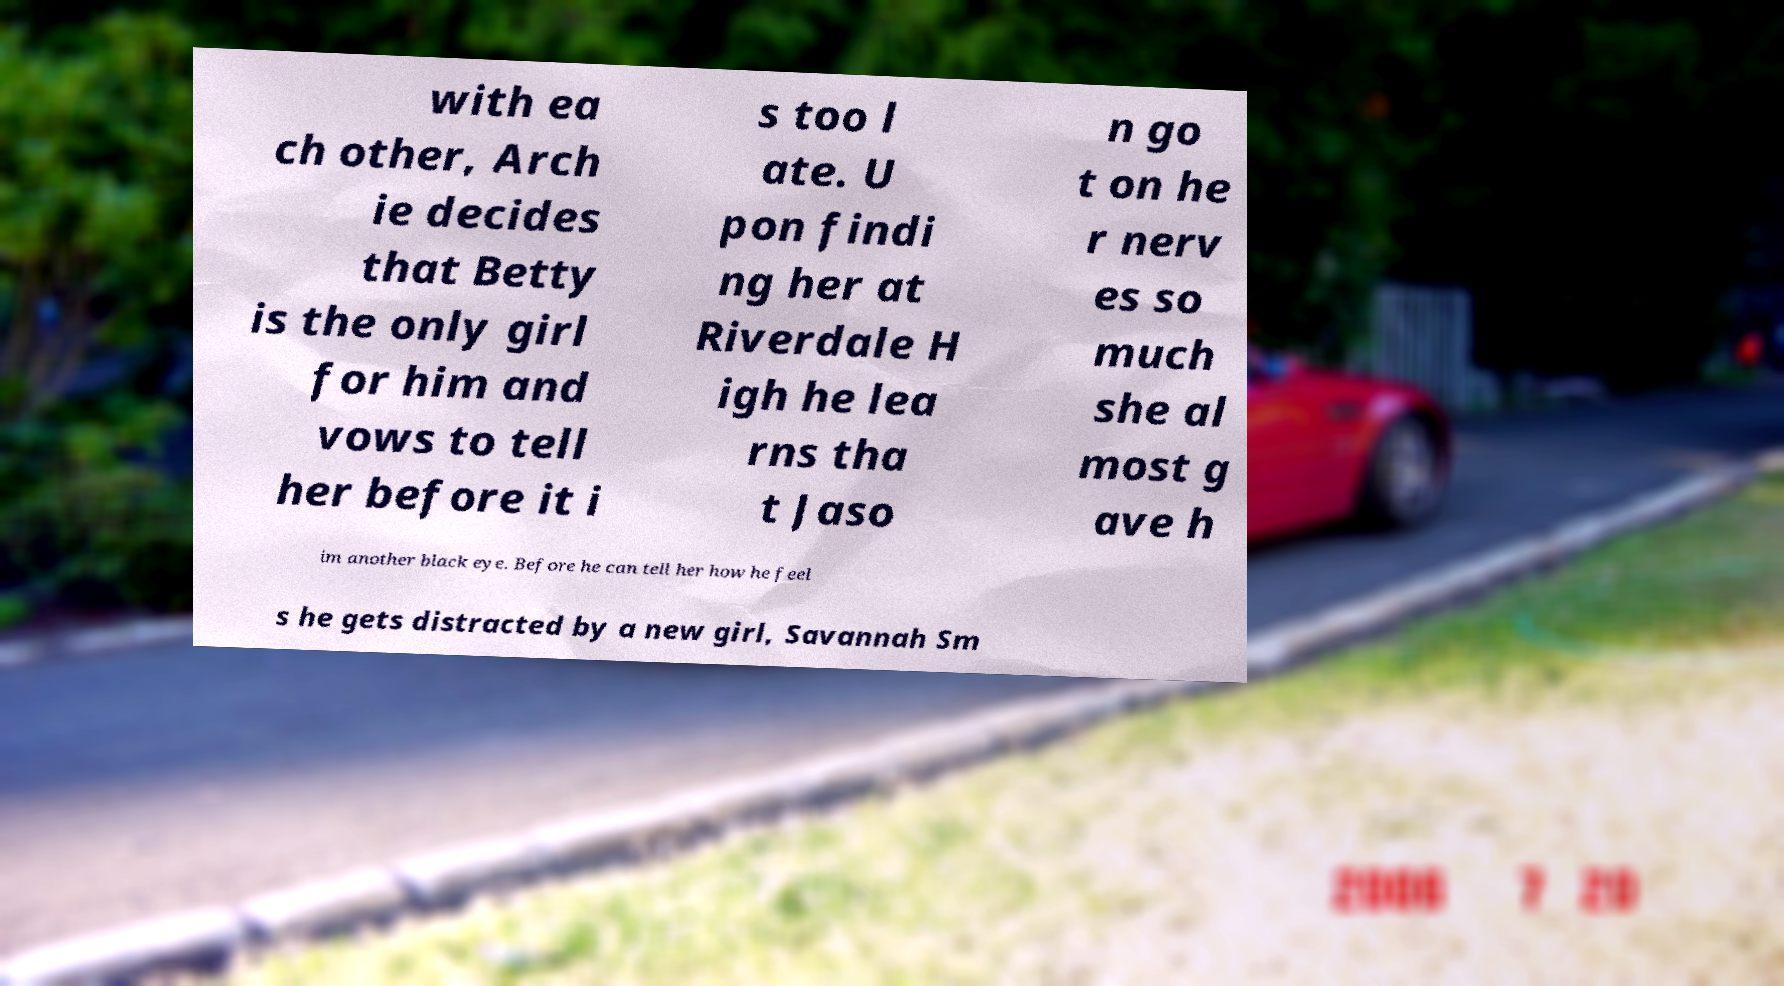I need the written content from this picture converted into text. Can you do that? with ea ch other, Arch ie decides that Betty is the only girl for him and vows to tell her before it i s too l ate. U pon findi ng her at Riverdale H igh he lea rns tha t Jaso n go t on he r nerv es so much she al most g ave h im another black eye. Before he can tell her how he feel s he gets distracted by a new girl, Savannah Sm 